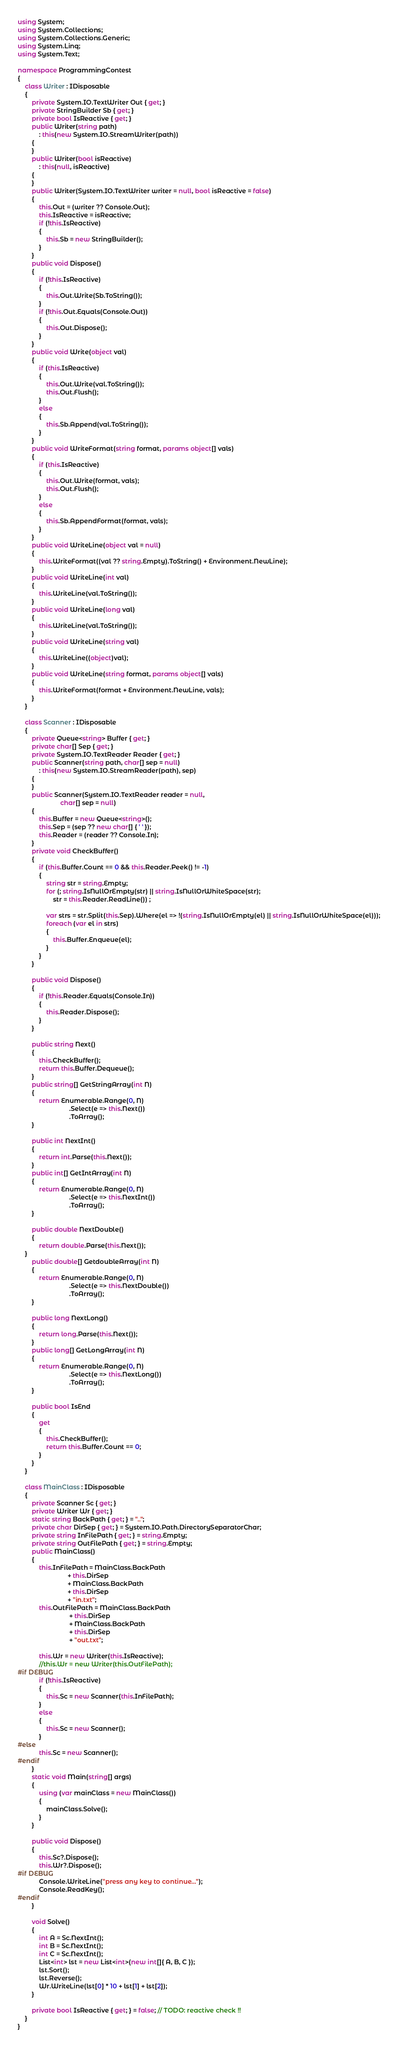Convert code to text. <code><loc_0><loc_0><loc_500><loc_500><_C#_>using System;
using System.Collections;
using System.Collections.Generic;
using System.Linq;
using System.Text;

namespace ProgrammingContest
{
    class Writer : IDisposable
    {
        private System.IO.TextWriter Out { get; }
        private StringBuilder Sb { get; }
        private bool IsReactive { get; }
        public Writer(string path)
            : this(new System.IO.StreamWriter(path))
        {
        }
        public Writer(bool isReactive)
            : this(null, isReactive)
        {
        }
        public Writer(System.IO.TextWriter writer = null, bool isReactive = false)
        {
            this.Out = (writer ?? Console.Out);
            this.IsReactive = isReactive;
            if (!this.IsReactive)
            {
                this.Sb = new StringBuilder();
            }
        }
        public void Dispose()
        {
            if (!this.IsReactive)
            {
                this.Out.Write(Sb.ToString());
            }
            if (!this.Out.Equals(Console.Out))
            {
                this.Out.Dispose();
            }
        }
        public void Write(object val)
        {
            if (this.IsReactive)
            {
                this.Out.Write(val.ToString());
                this.Out.Flush();
            }
            else
            {
                this.Sb.Append(val.ToString());
            }
        }
        public void WriteFormat(string format, params object[] vals)
        {
            if (this.IsReactive)
            {
                this.Out.Write(format, vals);
                this.Out.Flush();
            }
            else
            {
                this.Sb.AppendFormat(format, vals);
            }
        }
        public void WriteLine(object val = null)
        {
            this.WriteFormat((val ?? string.Empty).ToString() + Environment.NewLine);
        }
        public void WriteLine(int val)
        {
            this.WriteLine(val.ToString());
        }
        public void WriteLine(long val)
        {
            this.WriteLine(val.ToString());
        }
        public void WriteLine(string val)
        {
            this.WriteLine((object)val);
        }
        public void WriteLine(string format, params object[] vals)
        {
            this.WriteFormat(format + Environment.NewLine, vals);
        }
    }

    class Scanner : IDisposable
    {
        private Queue<string> Buffer { get; }
        private char[] Sep { get; }
        private System.IO.TextReader Reader { get; }
        public Scanner(string path, char[] sep = null)
            : this(new System.IO.StreamReader(path), sep)
        {
        }
        public Scanner(System.IO.TextReader reader = null,
                        char[] sep = null)
        {
            this.Buffer = new Queue<string>();
            this.Sep = (sep ?? new char[] { ' ' });
            this.Reader = (reader ?? Console.In);
        }
        private void CheckBuffer()
        {
            if (this.Buffer.Count == 0 && this.Reader.Peek() != -1)
            {
                string str = string.Empty;
                for (; string.IsNullOrEmpty(str) || string.IsNullOrWhiteSpace(str);
                    str = this.Reader.ReadLine()) ;

                var strs = str.Split(this.Sep).Where(el => !(string.IsNullOrEmpty(el) || string.IsNullOrWhiteSpace(el)));
                foreach (var el in strs)
                {
                    this.Buffer.Enqueue(el);
                }
            }
        }

        public void Dispose()
        {
            if (!this.Reader.Equals(Console.In))
            {
                this.Reader.Dispose();
            }
        }

        public string Next()
        {
            this.CheckBuffer();
            return this.Buffer.Dequeue();
        }
        public string[] GetStringArray(int N)
        {
            return Enumerable.Range(0, N)
                             .Select(e => this.Next())
                             .ToArray();
        }

        public int NextInt()
        {
            return int.Parse(this.Next());
        }
        public int[] GetIntArray(int N)
        {
            return Enumerable.Range(0, N)
                             .Select(e => this.NextInt())
                             .ToArray();
        }

        public double NextDouble()
        {
            return double.Parse(this.Next());
    }
        public double[] GetdoubleArray(int N)
        {
            return Enumerable.Range(0, N)
                             .Select(e => this.NextDouble())
                             .ToArray();
        }

        public long NextLong()
        {
            return long.Parse(this.Next());
        }
        public long[] GetLongArray(int N)
        {
            return Enumerable.Range(0, N)
                             .Select(e => this.NextLong())
                             .ToArray();
        }

        public bool IsEnd
        {
            get
            {
                this.CheckBuffer();
                return this.Buffer.Count == 0;
            }
        }
    }

    class MainClass : IDisposable
    {
        private Scanner Sc { get; }
        private Writer Wr { get; }
        static string BackPath { get; } = "..";
        private char DirSep { get; } = System.IO.Path.DirectorySeparatorChar;
        private string InFilePath { get; } = string.Empty;
        private string OutFilePath { get; } = string.Empty;
        public MainClass()
        {
            this.InFilePath = MainClass.BackPath
                            + this.DirSep
                            + MainClass.BackPath
                            + this.DirSep
                            + "in.txt";
            this.OutFilePath = MainClass.BackPath
                             + this.DirSep
                             + MainClass.BackPath
                             + this.DirSep
                             + "out.txt";

            this.Wr = new Writer(this.IsReactive);
            //this.Wr = new Writer(this.OutFilePath);
#if DEBUG
            if (!this.IsReactive)
            {
                this.Sc = new Scanner(this.InFilePath);
            }
            else
            {
                this.Sc = new Scanner();
            }
#else
            this.Sc = new Scanner();
#endif
        }
        static void Main(string[] args)
        {
            using (var mainClass = new MainClass())
            {
                mainClass.Solve();
            }
        }

        public void Dispose()
        {
            this.Sc?.Dispose();
            this.Wr?.Dispose();
#if DEBUG
            Console.WriteLine("press any key to continue...");
            Console.ReadKey();
#endif
        }

        void Solve()
        {
            int A = Sc.NextInt();
            int B = Sc.NextInt();
            int C = Sc.NextInt();
            List<int> lst = new List<int>(new int[]{ A, B, C });
            lst.Sort();
            lst.Reverse();
            Wr.WriteLine(lst[0] * 10 + lst[1] + lst[2]);
        }

        private bool IsReactive { get; } = false; // TODO: reactive check !!
    }
}
</code> 